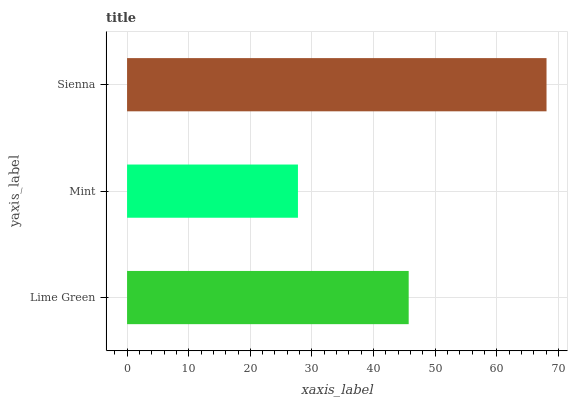Is Mint the minimum?
Answer yes or no. Yes. Is Sienna the maximum?
Answer yes or no. Yes. Is Sienna the minimum?
Answer yes or no. No. Is Mint the maximum?
Answer yes or no. No. Is Sienna greater than Mint?
Answer yes or no. Yes. Is Mint less than Sienna?
Answer yes or no. Yes. Is Mint greater than Sienna?
Answer yes or no. No. Is Sienna less than Mint?
Answer yes or no. No. Is Lime Green the high median?
Answer yes or no. Yes. Is Lime Green the low median?
Answer yes or no. Yes. Is Mint the high median?
Answer yes or no. No. Is Mint the low median?
Answer yes or no. No. 